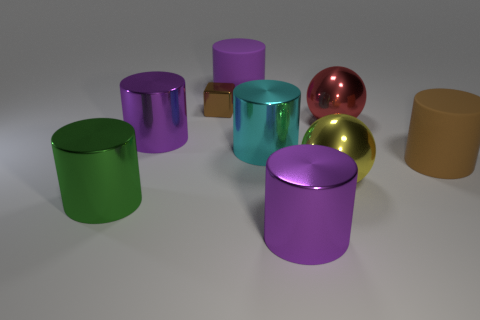What is the material of the large purple thing behind the big purple metallic cylinder that is left of the purple metal thing right of the tiny brown metal thing?
Provide a short and direct response. Rubber. There is another thing that is the same color as the small metal object; what is its material?
Ensure brevity in your answer.  Rubber. How many big purple things have the same material as the red object?
Offer a very short reply. 2. There is a brown thing to the left of the brown rubber object; is its size the same as the big green object?
Provide a short and direct response. No. There is a ball that is the same material as the yellow thing; what is its color?
Provide a short and direct response. Red. Is there any other thing that has the same size as the cyan cylinder?
Offer a very short reply. Yes. There is a large brown matte cylinder; what number of large metallic things are behind it?
Make the answer very short. 3. Do the shiny cylinder that is in front of the large green cylinder and the rubber cylinder that is on the left side of the cyan shiny cylinder have the same color?
Provide a succinct answer. Yes. There is another matte object that is the same shape as the large brown rubber object; what is its color?
Offer a terse response. Purple. Are there any other things that are the same shape as the tiny shiny thing?
Make the answer very short. No. 